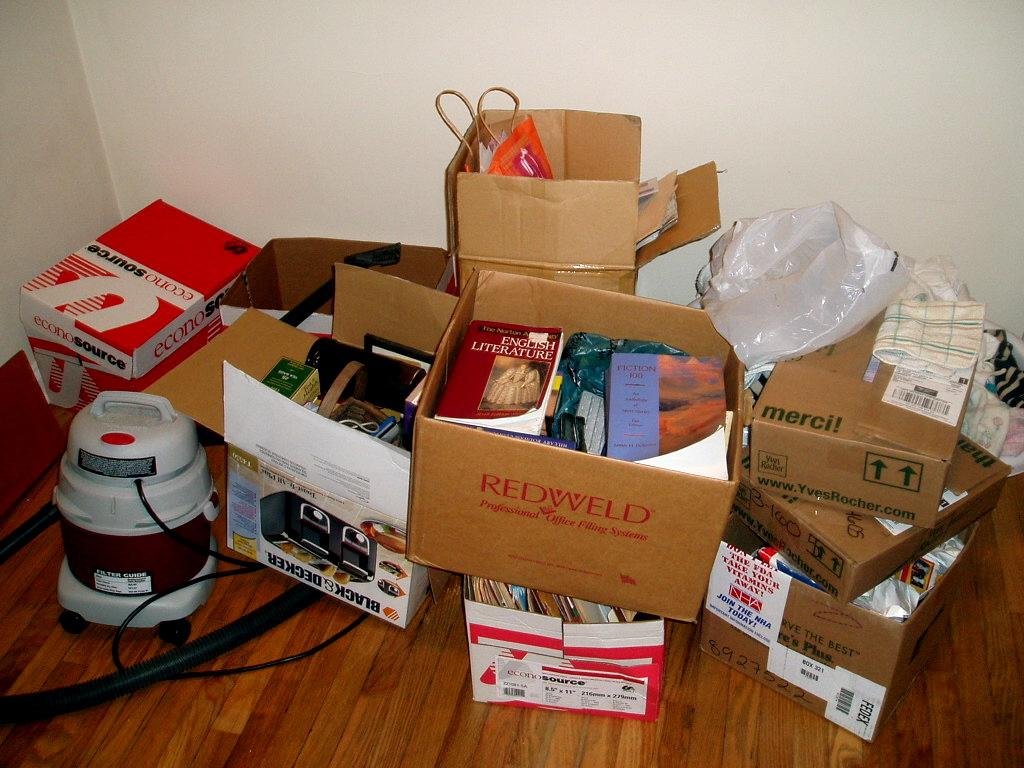<image>
Offer a succinct explanation of the picture presented. Many boxes of items on the ground with one brown box saying "Redweld". 